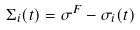<formula> <loc_0><loc_0><loc_500><loc_500>\Sigma _ { i } ( t ) = \sigma ^ { F } - \sigma _ { i } ( t )</formula> 